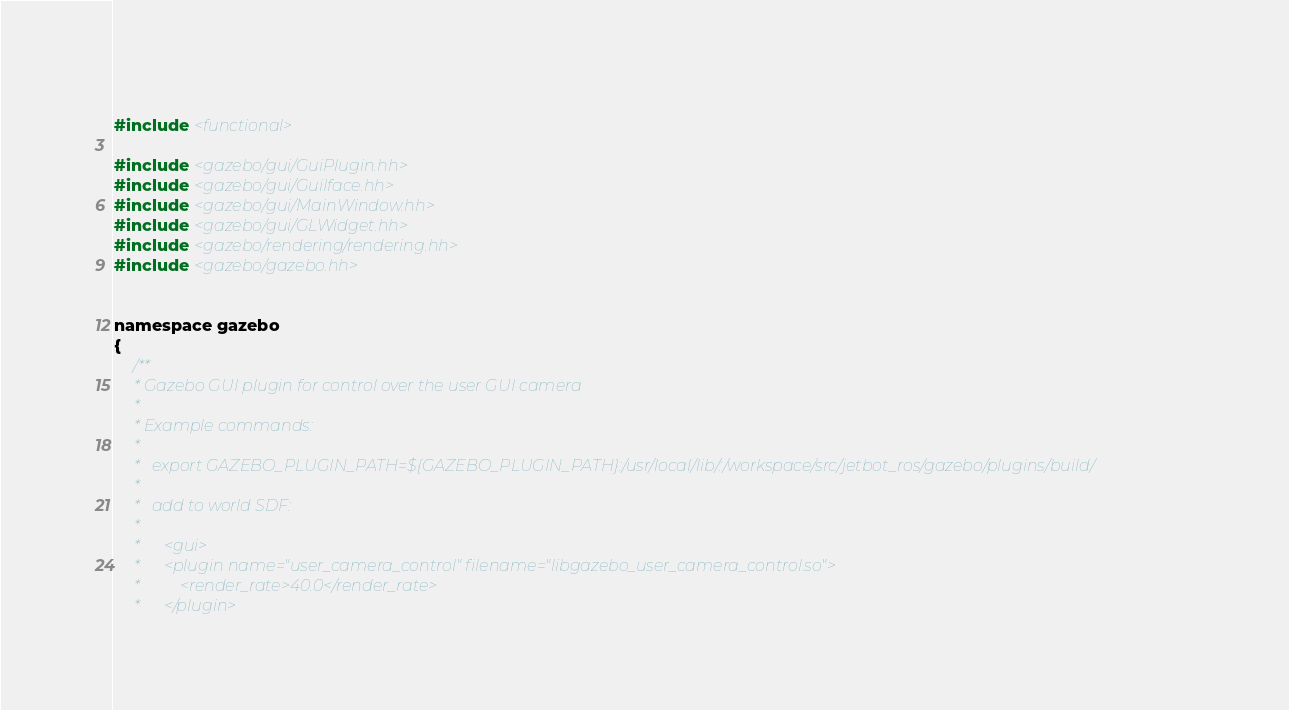Convert code to text. <code><loc_0><loc_0><loc_500><loc_500><_C_> 
#include <functional>

#include <gazebo/gui/GuiPlugin.hh>
#include <gazebo/gui/GuiIface.hh>
#include <gazebo/gui/MainWindow.hh>
#include <gazebo/gui/GLWidget.hh>
#include <gazebo/rendering/rendering.hh>
#include <gazebo/gazebo.hh>


namespace gazebo
{
	/**
	 * Gazebo GUI plugin for control over the user GUI camera
	 *
	 * Example commands:
	 *
	 *   export GAZEBO_PLUGIN_PATH=${GAZEBO_PLUGIN_PATH}:/usr/local/lib/:/workspace/src/jetbot_ros/gazebo/plugins/build/
	 *
	 *   add to world SDF:
	 *
	 *      <gui>
	 *		<plugin name="user_camera_control" filename="libgazebo_user_camera_control.so">
	 *			<render_rate>40.0</render_rate>
	 *		</plugin></code> 